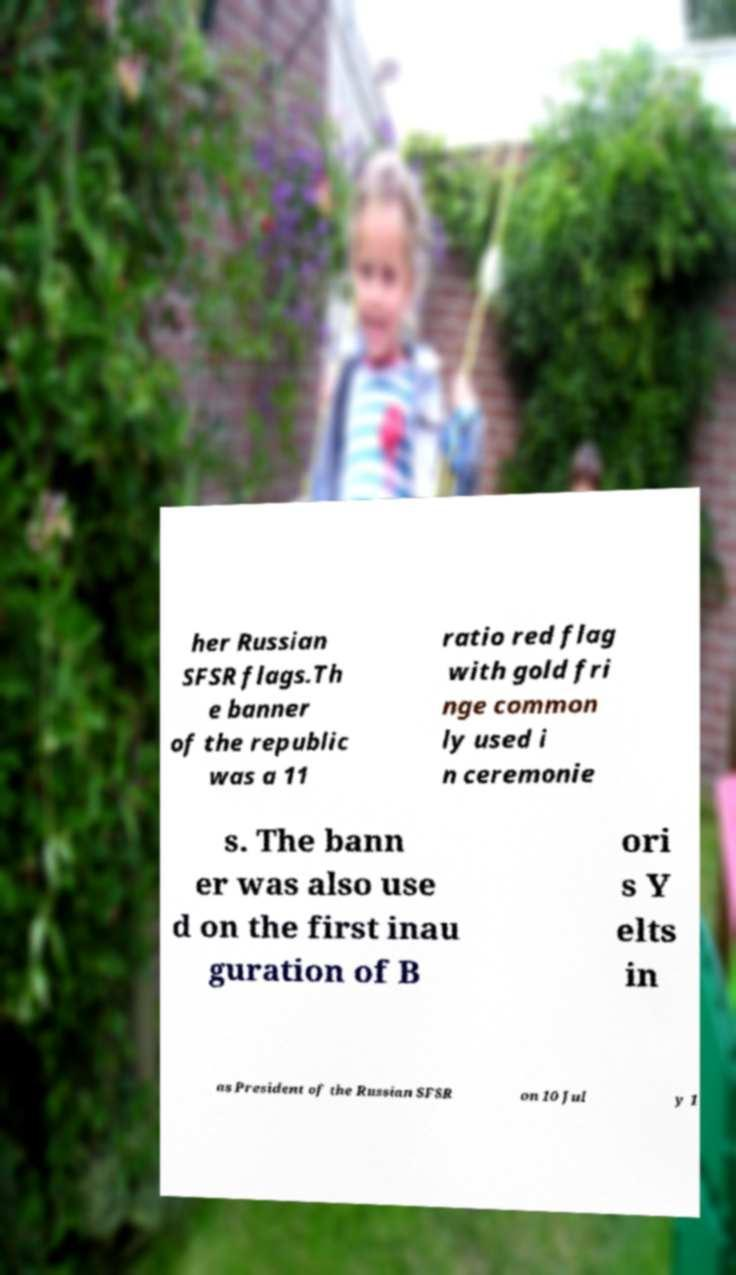Can you accurately transcribe the text from the provided image for me? her Russian SFSR flags.Th e banner of the republic was a 11 ratio red flag with gold fri nge common ly used i n ceremonie s. The bann er was also use d on the first inau guration of B ori s Y elts in as President of the Russian SFSR on 10 Jul y 1 